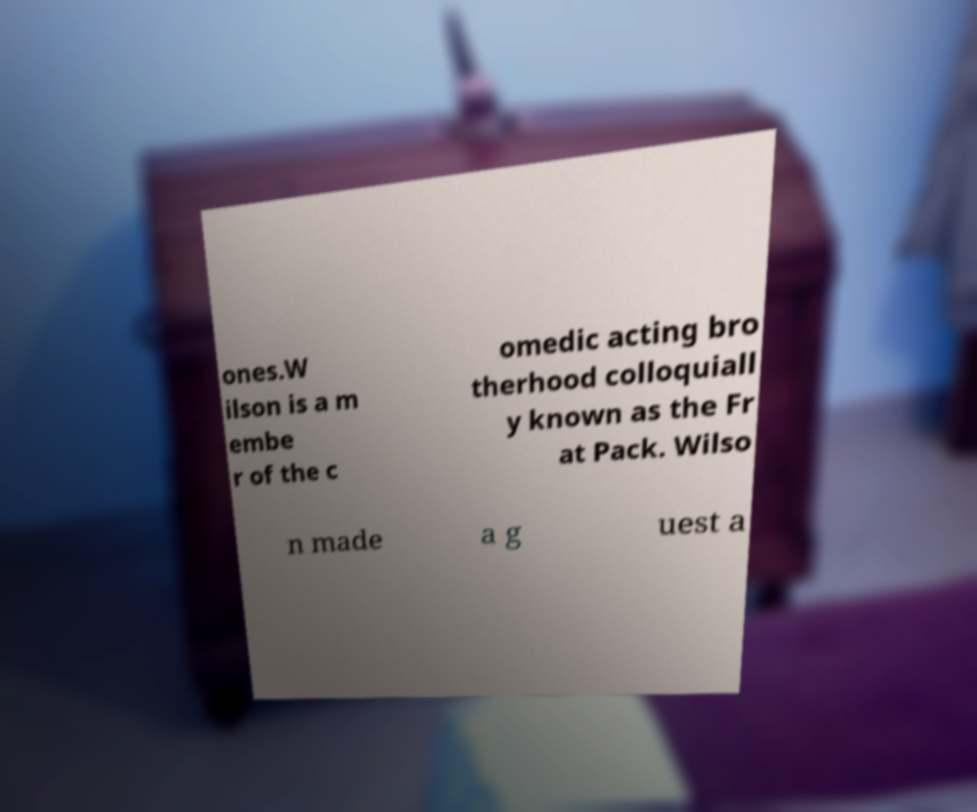For documentation purposes, I need the text within this image transcribed. Could you provide that? ones.W ilson is a m embe r of the c omedic acting bro therhood colloquiall y known as the Fr at Pack. Wilso n made a g uest a 